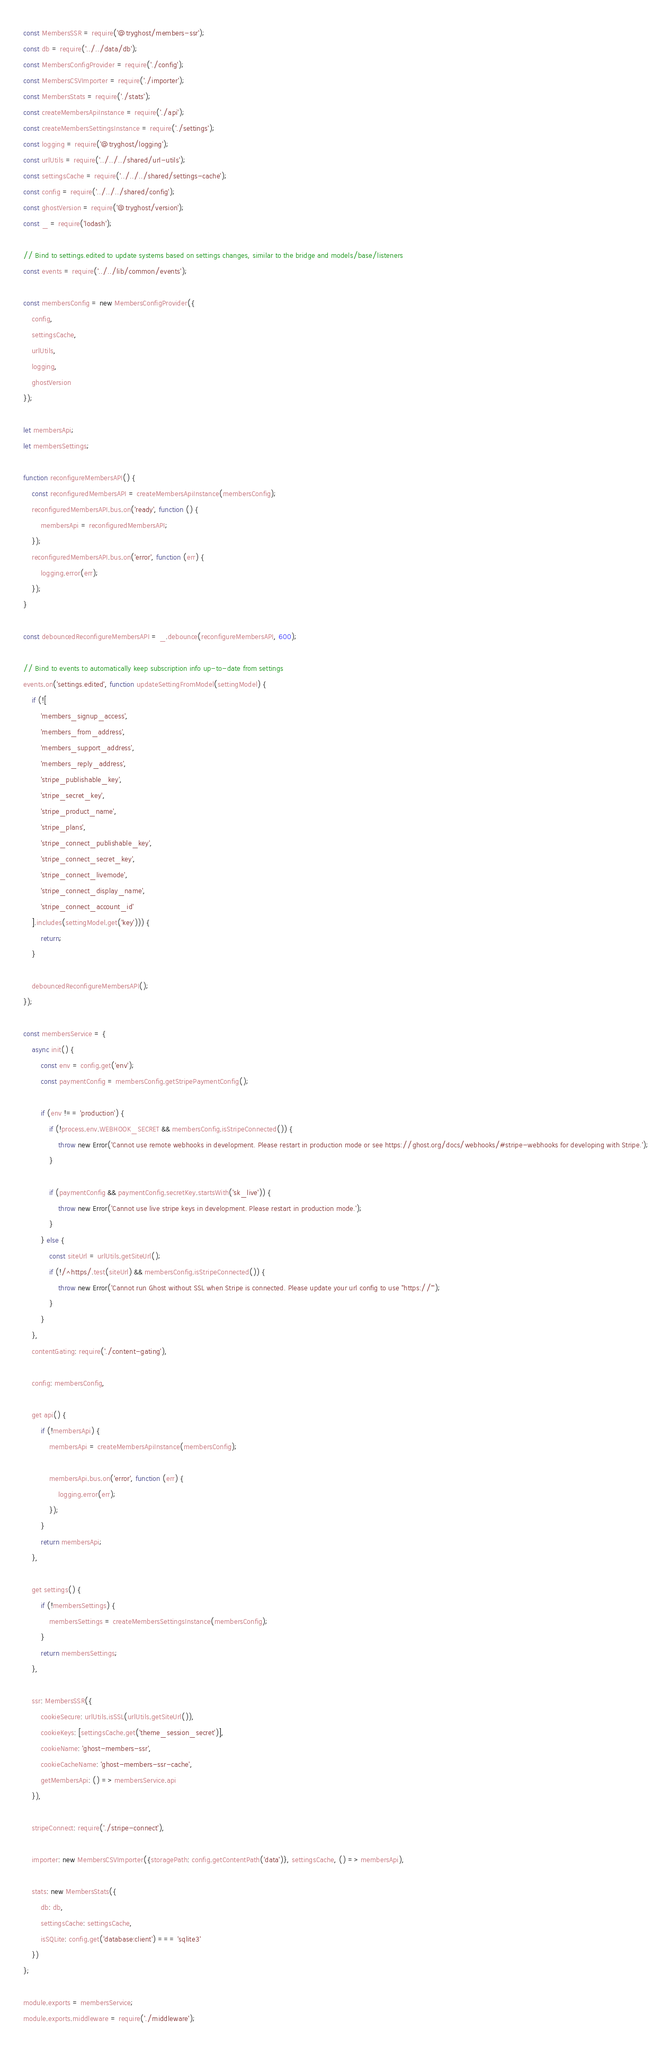<code> <loc_0><loc_0><loc_500><loc_500><_JavaScript_>const MembersSSR = require('@tryghost/members-ssr');
const db = require('../../data/db');
const MembersConfigProvider = require('./config');
const MembersCSVImporter = require('./importer');
const MembersStats = require('./stats');
const createMembersApiInstance = require('./api');
const createMembersSettingsInstance = require('./settings');
const logging = require('@tryghost/logging');
const urlUtils = require('../../../shared/url-utils');
const settingsCache = require('../../../shared/settings-cache');
const config = require('../../../shared/config');
const ghostVersion = require('@tryghost/version');
const _ = require('lodash');

// Bind to settings.edited to update systems based on settings changes, similar to the bridge and models/base/listeners
const events = require('../../lib/common/events');

const membersConfig = new MembersConfigProvider({
    config,
    settingsCache,
    urlUtils,
    logging,
    ghostVersion
});

let membersApi;
let membersSettings;

function reconfigureMembersAPI() {
    const reconfiguredMembersAPI = createMembersApiInstance(membersConfig);
    reconfiguredMembersAPI.bus.on('ready', function () {
        membersApi = reconfiguredMembersAPI;
    });
    reconfiguredMembersAPI.bus.on('error', function (err) {
        logging.error(err);
    });
}

const debouncedReconfigureMembersAPI = _.debounce(reconfigureMembersAPI, 600);

// Bind to events to automatically keep subscription info up-to-date from settings
events.on('settings.edited', function updateSettingFromModel(settingModel) {
    if (![
        'members_signup_access',
        'members_from_address',
        'members_support_address',
        'members_reply_address',
        'stripe_publishable_key',
        'stripe_secret_key',
        'stripe_product_name',
        'stripe_plans',
        'stripe_connect_publishable_key',
        'stripe_connect_secret_key',
        'stripe_connect_livemode',
        'stripe_connect_display_name',
        'stripe_connect_account_id'
    ].includes(settingModel.get('key'))) {
        return;
    }

    debouncedReconfigureMembersAPI();
});

const membersService = {
    async init() {
        const env = config.get('env');
        const paymentConfig = membersConfig.getStripePaymentConfig();

        if (env !== 'production') {
            if (!process.env.WEBHOOK_SECRET && membersConfig.isStripeConnected()) {
                throw new Error('Cannot use remote webhooks in development. Please restart in production mode or see https://ghost.org/docs/webhooks/#stripe-webhooks for developing with Stripe.');
            }

            if (paymentConfig && paymentConfig.secretKey.startsWith('sk_live')) {
                throw new Error('Cannot use live stripe keys in development. Please restart in production mode.');
            }
        } else {
            const siteUrl = urlUtils.getSiteUrl();
            if (!/^https/.test(siteUrl) && membersConfig.isStripeConnected()) {
                throw new Error('Cannot run Ghost without SSL when Stripe is connected. Please update your url config to use "https://"');
            }
        }
    },
    contentGating: require('./content-gating'),

    config: membersConfig,

    get api() {
        if (!membersApi) {
            membersApi = createMembersApiInstance(membersConfig);

            membersApi.bus.on('error', function (err) {
                logging.error(err);
            });
        }
        return membersApi;
    },

    get settings() {
        if (!membersSettings) {
            membersSettings = createMembersSettingsInstance(membersConfig);
        }
        return membersSettings;
    },

    ssr: MembersSSR({
        cookieSecure: urlUtils.isSSL(urlUtils.getSiteUrl()),
        cookieKeys: [settingsCache.get('theme_session_secret')],
        cookieName: 'ghost-members-ssr',
        cookieCacheName: 'ghost-members-ssr-cache',
        getMembersApi: () => membersService.api
    }),

    stripeConnect: require('./stripe-connect'),

    importer: new MembersCSVImporter({storagePath: config.getContentPath('data')}, settingsCache, () => membersApi),

    stats: new MembersStats({
        db: db,
        settingsCache: settingsCache,
        isSQLite: config.get('database:client') === 'sqlite3'
    })
};

module.exports = membersService;
module.exports.middleware = require('./middleware');
</code> 